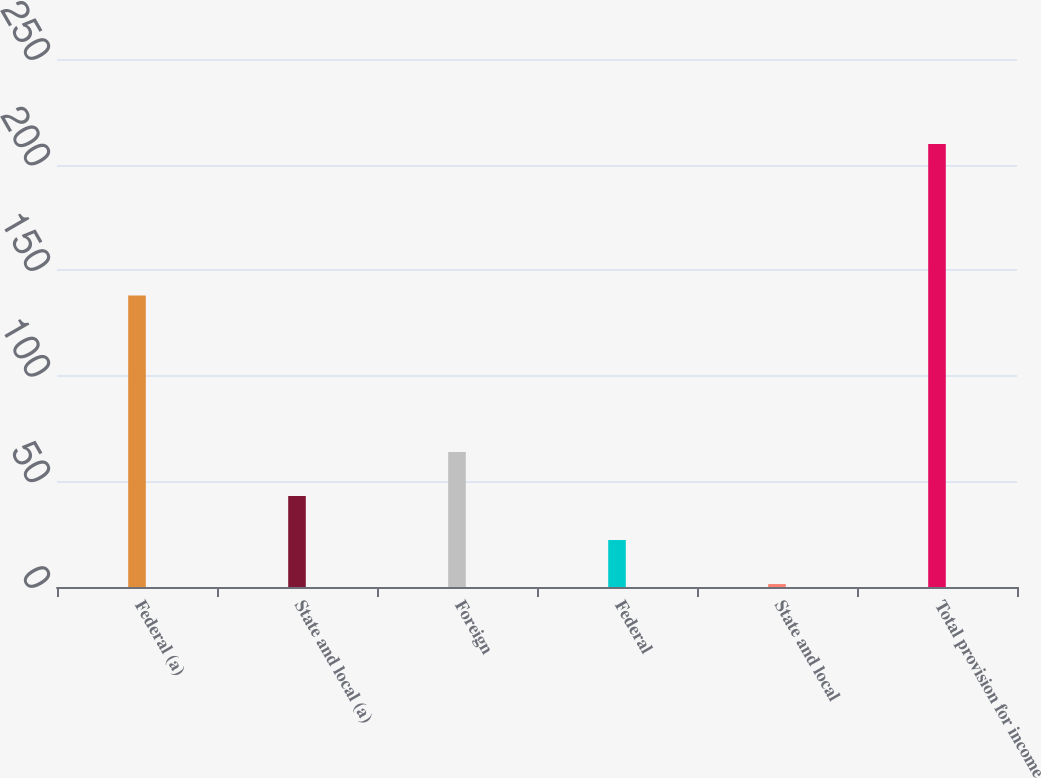Convert chart. <chart><loc_0><loc_0><loc_500><loc_500><bar_chart><fcel>Federal (a)<fcel>State and local (a)<fcel>Foreign<fcel>Federal<fcel>State and local<fcel>Total provision for income<nl><fcel>138<fcel>43.08<fcel>63.92<fcel>22.24<fcel>1.4<fcel>209.8<nl></chart> 